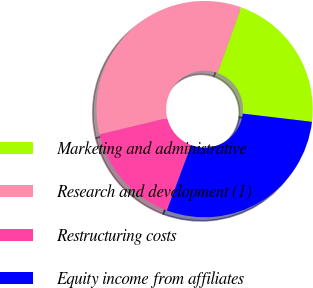<chart> <loc_0><loc_0><loc_500><loc_500><pie_chart><fcel>Marketing and administrative<fcel>Research and development (1)<fcel>Restructuring costs<fcel>Equity income from affiliates<nl><fcel>21.4%<fcel>34.24%<fcel>15.56%<fcel>28.79%<nl></chart> 